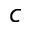Convert formula to latex. <formula><loc_0><loc_0><loc_500><loc_500>c</formula> 